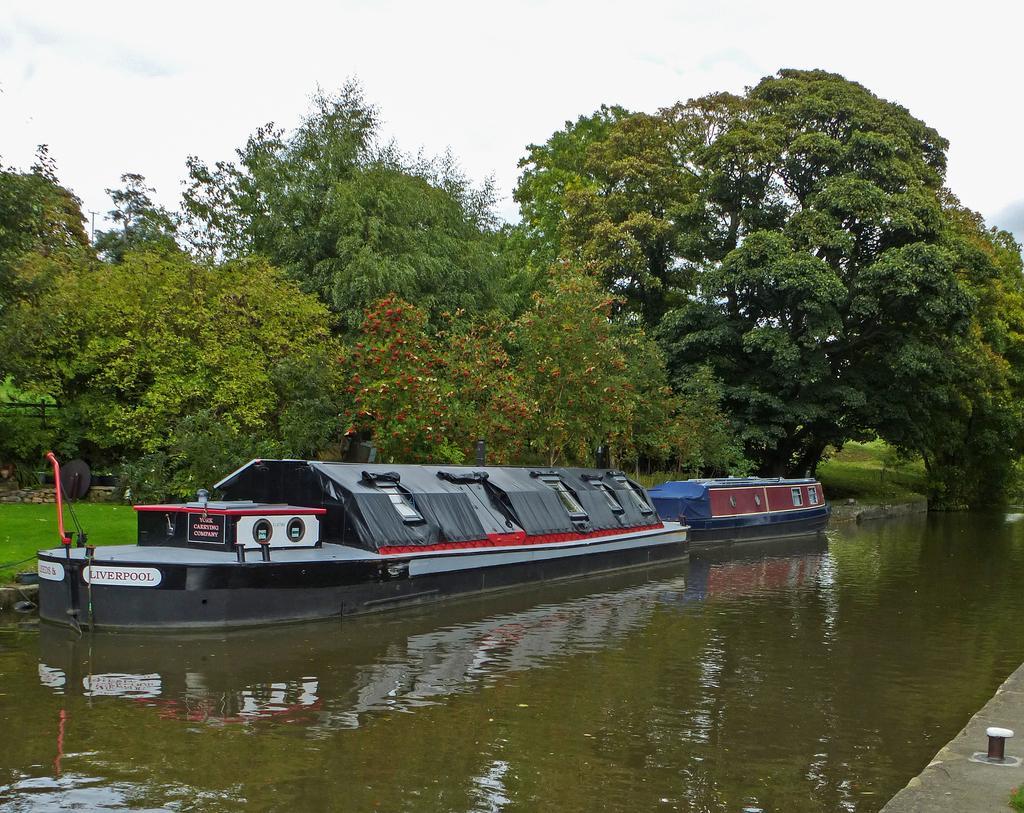In one or two sentences, can you explain what this image depicts? In this image we can see boats on the water, there are some trees and grass, in the background we can see the sky. 